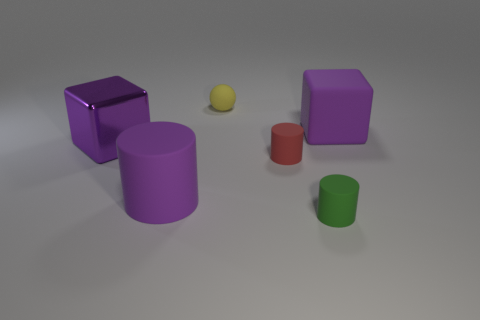What material is the thing that is behind the purple matte thing that is to the right of the big matte object on the left side of the small green rubber cylinder?
Give a very brief answer. Rubber. Are there any other things that have the same size as the yellow matte thing?
Your answer should be compact. Yes. There is a purple block that is the same material as the large purple cylinder; what is its size?
Your answer should be compact. Large. There is a tiny yellow object; what shape is it?
Keep it short and to the point. Sphere. Is the ball made of the same material as the big cube on the right side of the big matte cylinder?
Ensure brevity in your answer.  Yes. What number of things are either big gray metal blocks or small balls?
Give a very brief answer. 1. Are any blue matte cylinders visible?
Your response must be concise. No. There is a thing that is in front of the large rubber object to the left of the green rubber thing; what is its shape?
Your answer should be very brief. Cylinder. What number of objects are either purple matte things that are right of the tiny yellow matte ball or cubes that are on the right side of the tiny red thing?
Provide a short and direct response. 1. There is another block that is the same size as the purple rubber cube; what is it made of?
Your answer should be very brief. Metal. 